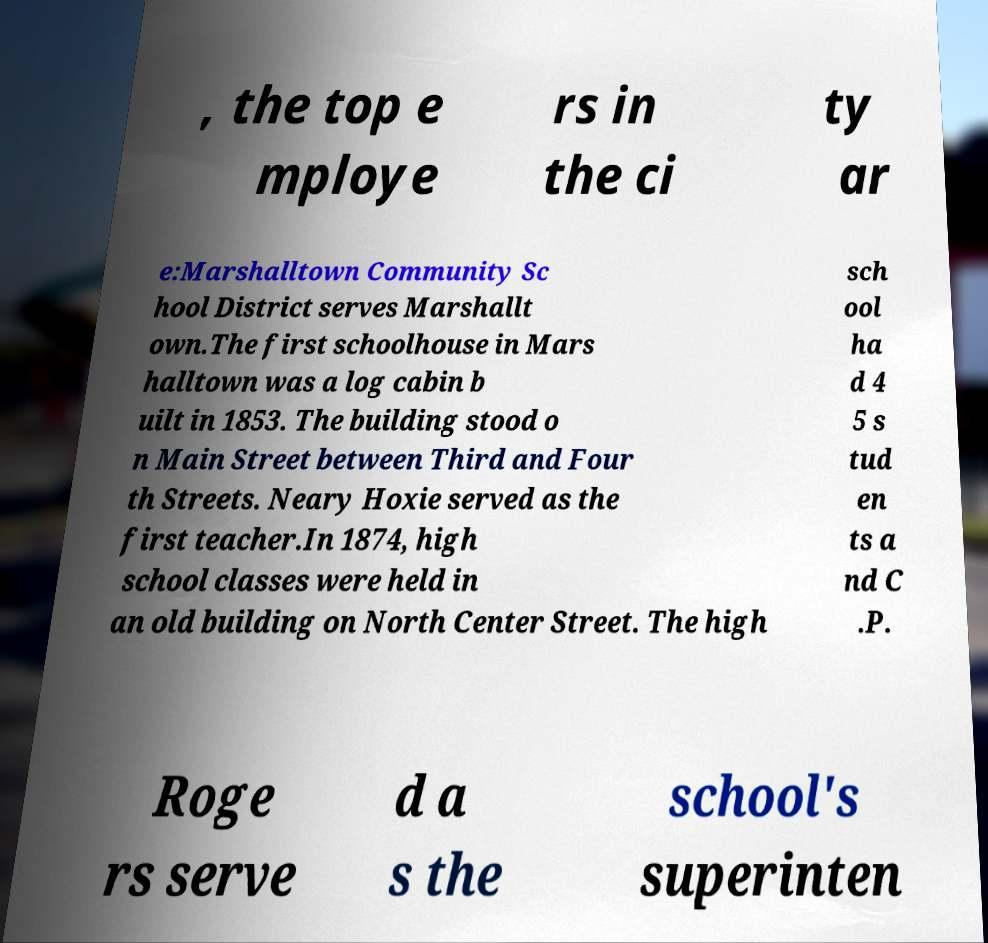For documentation purposes, I need the text within this image transcribed. Could you provide that? , the top e mploye rs in the ci ty ar e:Marshalltown Community Sc hool District serves Marshallt own.The first schoolhouse in Mars halltown was a log cabin b uilt in 1853. The building stood o n Main Street between Third and Four th Streets. Neary Hoxie served as the first teacher.In 1874, high school classes were held in an old building on North Center Street. The high sch ool ha d 4 5 s tud en ts a nd C .P. Roge rs serve d a s the school's superinten 